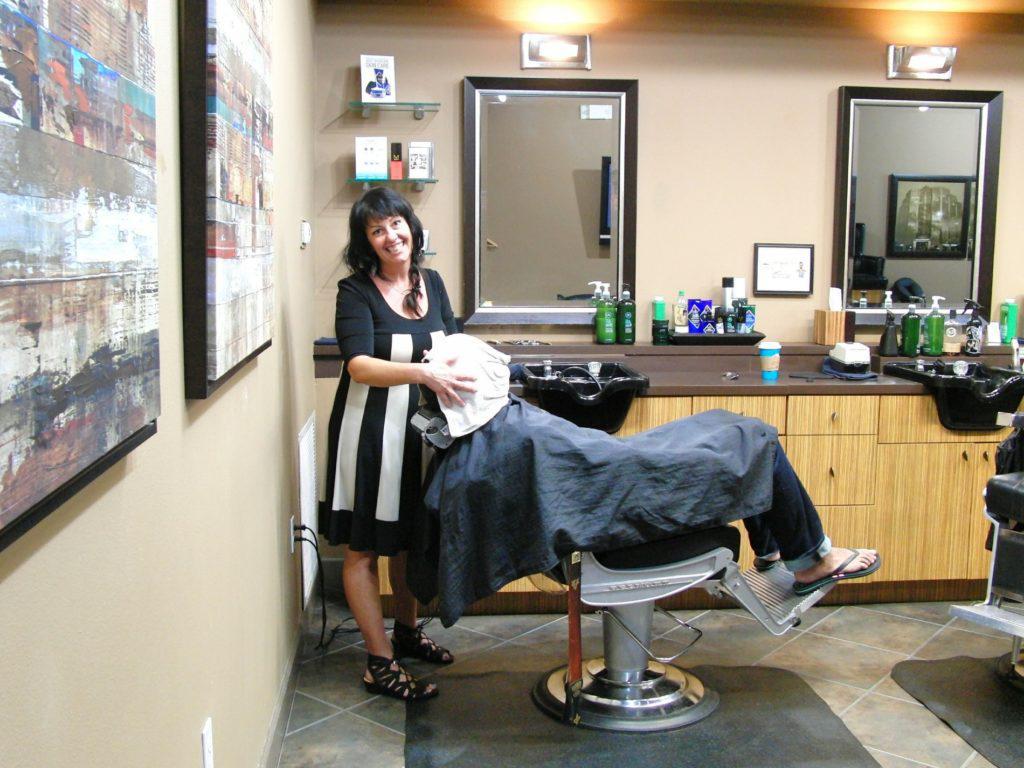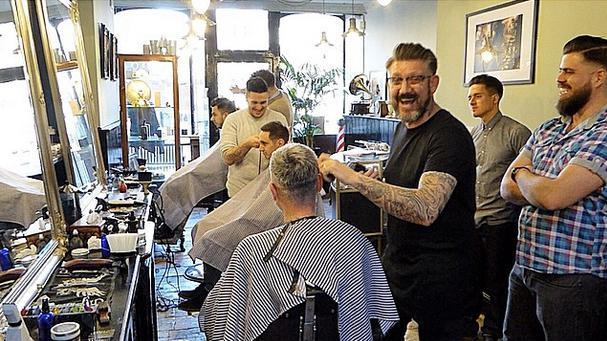The first image is the image on the left, the second image is the image on the right. For the images shown, is this caption "There are exactly two people in the left image." true? Answer yes or no. Yes. The first image is the image on the left, the second image is the image on the right. Analyze the images presented: Is the assertion "In at least one image there are two visible faces in the barbershop." valid? Answer yes or no. No. 